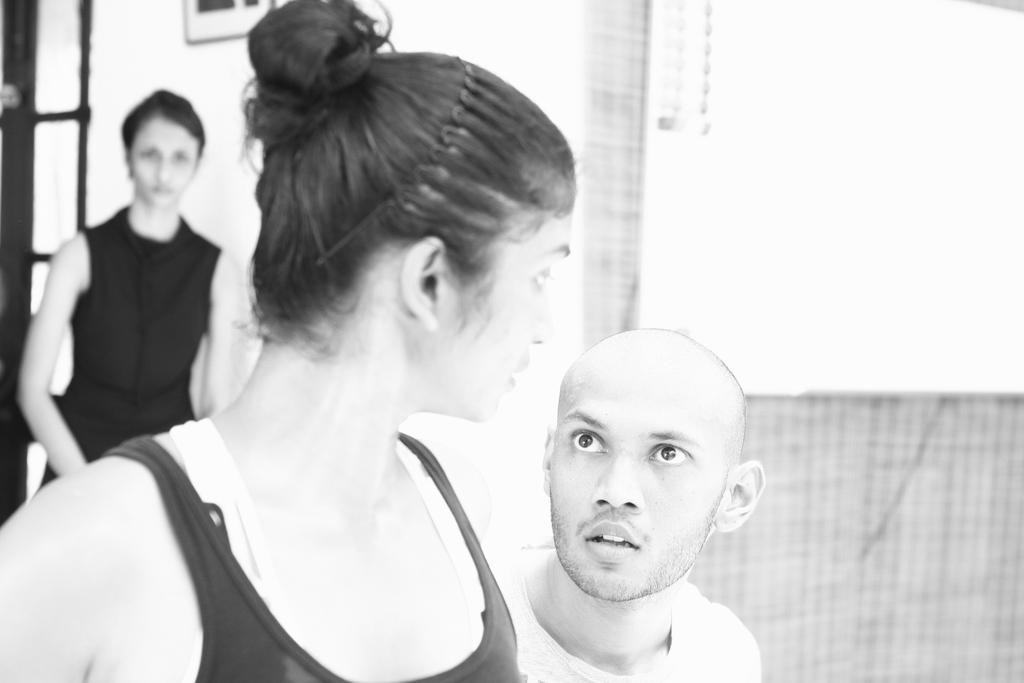Who or what can be seen in the image? There are people in the image. What is the background or setting of the image? There is a wall in the image. What type of jeans are the people wearing in the image? There is no information about the type of jeans the people are wearing in the image. 